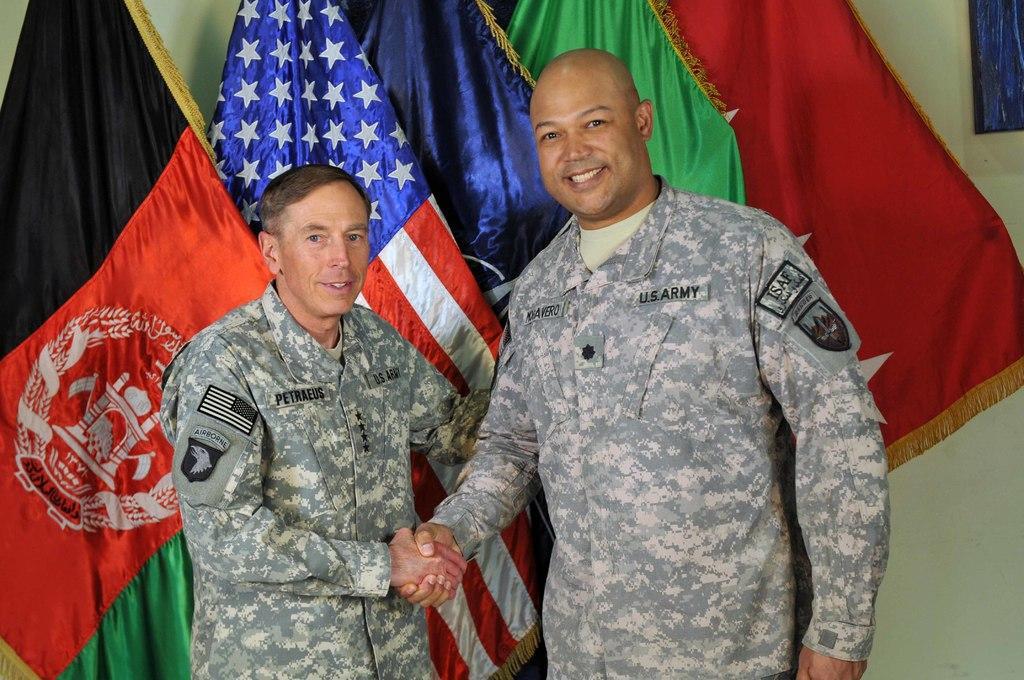In one or two sentences, can you explain what this image depicts? This picture is is clicked inside. In the foreground we can see the two persons wearing uniforms, smiling, shaking hands and standing on the ground. In the background we can see the flowers of different colors and we can see the wall. 